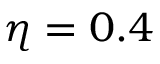<formula> <loc_0><loc_0><loc_500><loc_500>\eta = 0 . 4</formula> 